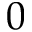Convert formula to latex. <formula><loc_0><loc_0><loc_500><loc_500>0</formula> 